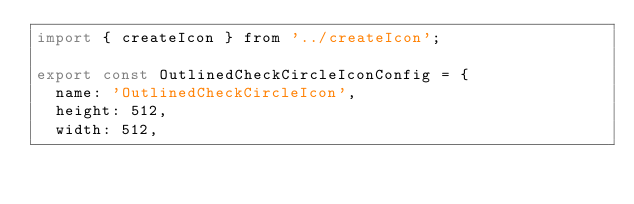Convert code to text. <code><loc_0><loc_0><loc_500><loc_500><_JavaScript_>import { createIcon } from '../createIcon';

export const OutlinedCheckCircleIconConfig = {
  name: 'OutlinedCheckCircleIcon',
  height: 512,
  width: 512,</code> 